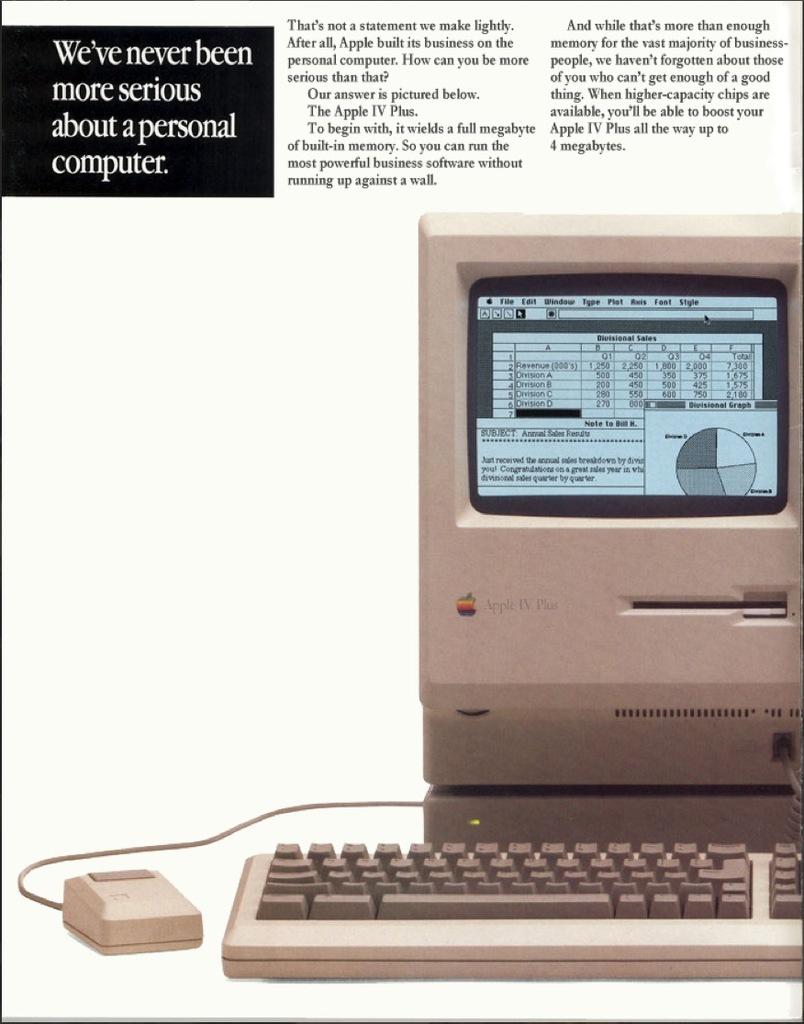What brand of computer is this?
Keep it short and to the point. Apple. We;ve never been more what?
Offer a terse response. Serious. 